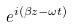<formula> <loc_0><loc_0><loc_500><loc_500>e ^ { i ( \beta z - \omega t ) }</formula> 